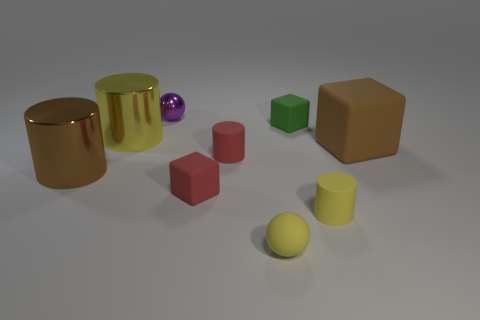Is there anything else that is the same size as the brown metallic cylinder?
Make the answer very short. Yes. What shape is the yellow object that is the same size as the brown shiny cylinder?
Offer a very short reply. Cylinder. Is there a small red object left of the rubber cylinder that is on the right side of the rubber cube behind the large yellow metal cylinder?
Keep it short and to the point. Yes. There is a large matte cube; does it have the same color as the cylinder that is behind the red rubber cylinder?
Give a very brief answer. No. What number of balls have the same color as the small metal thing?
Your response must be concise. 0. There is a metallic cylinder in front of the block right of the small yellow matte cylinder; how big is it?
Your answer should be very brief. Large. What number of objects are brown metallic cylinders that are behind the tiny red matte block or tiny brown metallic blocks?
Offer a very short reply. 1. Are there any other purple metallic spheres that have the same size as the metallic sphere?
Your answer should be very brief. No. There is a small ball that is in front of the big brown cylinder; are there any yellow objects left of it?
Your answer should be very brief. Yes. What number of cubes are either yellow metallic things or large things?
Your answer should be very brief. 1. 